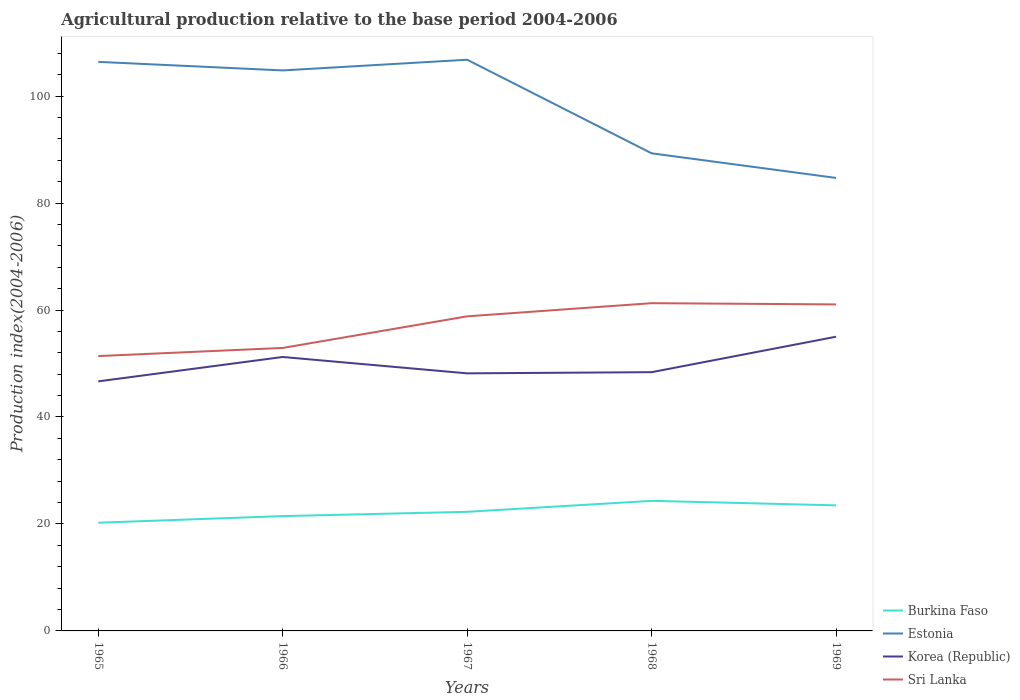Does the line corresponding to Estonia intersect with the line corresponding to Korea (Republic)?
Offer a very short reply. No. Across all years, what is the maximum agricultural production index in Burkina Faso?
Give a very brief answer. 20.23. In which year was the agricultural production index in Burkina Faso maximum?
Provide a succinct answer. 1965. What is the total agricultural production index in Sri Lanka in the graph?
Offer a terse response. -9.66. What is the difference between the highest and the second highest agricultural production index in Sri Lanka?
Your answer should be very brief. 9.89. What is the difference between the highest and the lowest agricultural production index in Sri Lanka?
Ensure brevity in your answer.  3. How many years are there in the graph?
Offer a very short reply. 5. Does the graph contain any zero values?
Your answer should be very brief. No. Does the graph contain grids?
Offer a very short reply. No. Where does the legend appear in the graph?
Offer a terse response. Bottom right. How many legend labels are there?
Keep it short and to the point. 4. How are the legend labels stacked?
Give a very brief answer. Vertical. What is the title of the graph?
Provide a succinct answer. Agricultural production relative to the base period 2004-2006. What is the label or title of the X-axis?
Provide a short and direct response. Years. What is the label or title of the Y-axis?
Offer a terse response. Production index(2004-2006). What is the Production index(2004-2006) in Burkina Faso in 1965?
Keep it short and to the point. 20.23. What is the Production index(2004-2006) in Estonia in 1965?
Offer a very short reply. 106.4. What is the Production index(2004-2006) of Korea (Republic) in 1965?
Make the answer very short. 46.66. What is the Production index(2004-2006) in Sri Lanka in 1965?
Your answer should be very brief. 51.39. What is the Production index(2004-2006) of Burkina Faso in 1966?
Ensure brevity in your answer.  21.47. What is the Production index(2004-2006) of Estonia in 1966?
Provide a succinct answer. 104.8. What is the Production index(2004-2006) of Korea (Republic) in 1966?
Make the answer very short. 51.22. What is the Production index(2004-2006) of Sri Lanka in 1966?
Offer a very short reply. 52.91. What is the Production index(2004-2006) in Burkina Faso in 1967?
Offer a terse response. 22.27. What is the Production index(2004-2006) in Estonia in 1967?
Provide a short and direct response. 106.8. What is the Production index(2004-2006) in Korea (Republic) in 1967?
Provide a succinct answer. 48.16. What is the Production index(2004-2006) of Sri Lanka in 1967?
Offer a terse response. 58.82. What is the Production index(2004-2006) of Burkina Faso in 1968?
Provide a short and direct response. 24.32. What is the Production index(2004-2006) of Estonia in 1968?
Your answer should be very brief. 89.3. What is the Production index(2004-2006) of Korea (Republic) in 1968?
Provide a succinct answer. 48.38. What is the Production index(2004-2006) in Sri Lanka in 1968?
Your answer should be compact. 61.28. What is the Production index(2004-2006) in Burkina Faso in 1969?
Provide a succinct answer. 23.48. What is the Production index(2004-2006) of Estonia in 1969?
Your response must be concise. 84.7. What is the Production index(2004-2006) of Korea (Republic) in 1969?
Provide a succinct answer. 55.01. What is the Production index(2004-2006) of Sri Lanka in 1969?
Provide a succinct answer. 61.05. Across all years, what is the maximum Production index(2004-2006) in Burkina Faso?
Give a very brief answer. 24.32. Across all years, what is the maximum Production index(2004-2006) of Estonia?
Your response must be concise. 106.8. Across all years, what is the maximum Production index(2004-2006) in Korea (Republic)?
Offer a very short reply. 55.01. Across all years, what is the maximum Production index(2004-2006) of Sri Lanka?
Your answer should be very brief. 61.28. Across all years, what is the minimum Production index(2004-2006) of Burkina Faso?
Offer a terse response. 20.23. Across all years, what is the minimum Production index(2004-2006) of Estonia?
Offer a very short reply. 84.7. Across all years, what is the minimum Production index(2004-2006) of Korea (Republic)?
Provide a succinct answer. 46.66. Across all years, what is the minimum Production index(2004-2006) of Sri Lanka?
Your answer should be compact. 51.39. What is the total Production index(2004-2006) in Burkina Faso in the graph?
Offer a terse response. 111.77. What is the total Production index(2004-2006) of Estonia in the graph?
Your response must be concise. 492. What is the total Production index(2004-2006) in Korea (Republic) in the graph?
Your answer should be very brief. 249.43. What is the total Production index(2004-2006) in Sri Lanka in the graph?
Offer a terse response. 285.45. What is the difference between the Production index(2004-2006) in Burkina Faso in 1965 and that in 1966?
Make the answer very short. -1.24. What is the difference between the Production index(2004-2006) in Estonia in 1965 and that in 1966?
Offer a very short reply. 1.6. What is the difference between the Production index(2004-2006) in Korea (Republic) in 1965 and that in 1966?
Offer a terse response. -4.56. What is the difference between the Production index(2004-2006) of Sri Lanka in 1965 and that in 1966?
Make the answer very short. -1.52. What is the difference between the Production index(2004-2006) in Burkina Faso in 1965 and that in 1967?
Give a very brief answer. -2.04. What is the difference between the Production index(2004-2006) of Estonia in 1965 and that in 1967?
Give a very brief answer. -0.4. What is the difference between the Production index(2004-2006) of Korea (Republic) in 1965 and that in 1967?
Provide a short and direct response. -1.5. What is the difference between the Production index(2004-2006) of Sri Lanka in 1965 and that in 1967?
Give a very brief answer. -7.43. What is the difference between the Production index(2004-2006) in Burkina Faso in 1965 and that in 1968?
Your answer should be compact. -4.09. What is the difference between the Production index(2004-2006) of Korea (Republic) in 1965 and that in 1968?
Make the answer very short. -1.72. What is the difference between the Production index(2004-2006) in Sri Lanka in 1965 and that in 1968?
Make the answer very short. -9.89. What is the difference between the Production index(2004-2006) of Burkina Faso in 1965 and that in 1969?
Offer a very short reply. -3.25. What is the difference between the Production index(2004-2006) in Estonia in 1965 and that in 1969?
Your answer should be very brief. 21.7. What is the difference between the Production index(2004-2006) in Korea (Republic) in 1965 and that in 1969?
Your answer should be compact. -8.35. What is the difference between the Production index(2004-2006) in Sri Lanka in 1965 and that in 1969?
Give a very brief answer. -9.66. What is the difference between the Production index(2004-2006) of Estonia in 1966 and that in 1967?
Make the answer very short. -2. What is the difference between the Production index(2004-2006) of Korea (Republic) in 1966 and that in 1967?
Offer a terse response. 3.06. What is the difference between the Production index(2004-2006) in Sri Lanka in 1966 and that in 1967?
Make the answer very short. -5.91. What is the difference between the Production index(2004-2006) of Burkina Faso in 1966 and that in 1968?
Make the answer very short. -2.85. What is the difference between the Production index(2004-2006) in Korea (Republic) in 1966 and that in 1968?
Your response must be concise. 2.84. What is the difference between the Production index(2004-2006) in Sri Lanka in 1966 and that in 1968?
Make the answer very short. -8.37. What is the difference between the Production index(2004-2006) of Burkina Faso in 1966 and that in 1969?
Provide a short and direct response. -2.01. What is the difference between the Production index(2004-2006) in Estonia in 1966 and that in 1969?
Your answer should be very brief. 20.1. What is the difference between the Production index(2004-2006) of Korea (Republic) in 1966 and that in 1969?
Offer a terse response. -3.79. What is the difference between the Production index(2004-2006) in Sri Lanka in 1966 and that in 1969?
Offer a very short reply. -8.14. What is the difference between the Production index(2004-2006) of Burkina Faso in 1967 and that in 1968?
Ensure brevity in your answer.  -2.05. What is the difference between the Production index(2004-2006) in Korea (Republic) in 1967 and that in 1968?
Offer a very short reply. -0.22. What is the difference between the Production index(2004-2006) of Sri Lanka in 1967 and that in 1968?
Offer a terse response. -2.46. What is the difference between the Production index(2004-2006) of Burkina Faso in 1967 and that in 1969?
Your answer should be compact. -1.21. What is the difference between the Production index(2004-2006) in Estonia in 1967 and that in 1969?
Your answer should be very brief. 22.1. What is the difference between the Production index(2004-2006) of Korea (Republic) in 1967 and that in 1969?
Your response must be concise. -6.85. What is the difference between the Production index(2004-2006) in Sri Lanka in 1967 and that in 1969?
Give a very brief answer. -2.23. What is the difference between the Production index(2004-2006) of Burkina Faso in 1968 and that in 1969?
Provide a succinct answer. 0.84. What is the difference between the Production index(2004-2006) of Estonia in 1968 and that in 1969?
Your answer should be compact. 4.6. What is the difference between the Production index(2004-2006) of Korea (Republic) in 1968 and that in 1969?
Your response must be concise. -6.63. What is the difference between the Production index(2004-2006) in Sri Lanka in 1968 and that in 1969?
Offer a very short reply. 0.23. What is the difference between the Production index(2004-2006) of Burkina Faso in 1965 and the Production index(2004-2006) of Estonia in 1966?
Keep it short and to the point. -84.57. What is the difference between the Production index(2004-2006) in Burkina Faso in 1965 and the Production index(2004-2006) in Korea (Republic) in 1966?
Give a very brief answer. -30.99. What is the difference between the Production index(2004-2006) in Burkina Faso in 1965 and the Production index(2004-2006) in Sri Lanka in 1966?
Offer a very short reply. -32.68. What is the difference between the Production index(2004-2006) of Estonia in 1965 and the Production index(2004-2006) of Korea (Republic) in 1966?
Provide a succinct answer. 55.18. What is the difference between the Production index(2004-2006) in Estonia in 1965 and the Production index(2004-2006) in Sri Lanka in 1966?
Ensure brevity in your answer.  53.49. What is the difference between the Production index(2004-2006) of Korea (Republic) in 1965 and the Production index(2004-2006) of Sri Lanka in 1966?
Your answer should be very brief. -6.25. What is the difference between the Production index(2004-2006) in Burkina Faso in 1965 and the Production index(2004-2006) in Estonia in 1967?
Offer a terse response. -86.57. What is the difference between the Production index(2004-2006) of Burkina Faso in 1965 and the Production index(2004-2006) of Korea (Republic) in 1967?
Give a very brief answer. -27.93. What is the difference between the Production index(2004-2006) of Burkina Faso in 1965 and the Production index(2004-2006) of Sri Lanka in 1967?
Offer a terse response. -38.59. What is the difference between the Production index(2004-2006) of Estonia in 1965 and the Production index(2004-2006) of Korea (Republic) in 1967?
Make the answer very short. 58.24. What is the difference between the Production index(2004-2006) in Estonia in 1965 and the Production index(2004-2006) in Sri Lanka in 1967?
Ensure brevity in your answer.  47.58. What is the difference between the Production index(2004-2006) in Korea (Republic) in 1965 and the Production index(2004-2006) in Sri Lanka in 1967?
Offer a very short reply. -12.16. What is the difference between the Production index(2004-2006) in Burkina Faso in 1965 and the Production index(2004-2006) in Estonia in 1968?
Offer a very short reply. -69.07. What is the difference between the Production index(2004-2006) of Burkina Faso in 1965 and the Production index(2004-2006) of Korea (Republic) in 1968?
Your answer should be compact. -28.15. What is the difference between the Production index(2004-2006) of Burkina Faso in 1965 and the Production index(2004-2006) of Sri Lanka in 1968?
Provide a short and direct response. -41.05. What is the difference between the Production index(2004-2006) of Estonia in 1965 and the Production index(2004-2006) of Korea (Republic) in 1968?
Your answer should be very brief. 58.02. What is the difference between the Production index(2004-2006) in Estonia in 1965 and the Production index(2004-2006) in Sri Lanka in 1968?
Offer a terse response. 45.12. What is the difference between the Production index(2004-2006) in Korea (Republic) in 1965 and the Production index(2004-2006) in Sri Lanka in 1968?
Provide a succinct answer. -14.62. What is the difference between the Production index(2004-2006) of Burkina Faso in 1965 and the Production index(2004-2006) of Estonia in 1969?
Keep it short and to the point. -64.47. What is the difference between the Production index(2004-2006) of Burkina Faso in 1965 and the Production index(2004-2006) of Korea (Republic) in 1969?
Your response must be concise. -34.78. What is the difference between the Production index(2004-2006) of Burkina Faso in 1965 and the Production index(2004-2006) of Sri Lanka in 1969?
Your answer should be compact. -40.82. What is the difference between the Production index(2004-2006) in Estonia in 1965 and the Production index(2004-2006) in Korea (Republic) in 1969?
Offer a terse response. 51.39. What is the difference between the Production index(2004-2006) in Estonia in 1965 and the Production index(2004-2006) in Sri Lanka in 1969?
Ensure brevity in your answer.  45.35. What is the difference between the Production index(2004-2006) of Korea (Republic) in 1965 and the Production index(2004-2006) of Sri Lanka in 1969?
Provide a short and direct response. -14.39. What is the difference between the Production index(2004-2006) in Burkina Faso in 1966 and the Production index(2004-2006) in Estonia in 1967?
Provide a short and direct response. -85.33. What is the difference between the Production index(2004-2006) of Burkina Faso in 1966 and the Production index(2004-2006) of Korea (Republic) in 1967?
Provide a succinct answer. -26.69. What is the difference between the Production index(2004-2006) in Burkina Faso in 1966 and the Production index(2004-2006) in Sri Lanka in 1967?
Offer a very short reply. -37.35. What is the difference between the Production index(2004-2006) in Estonia in 1966 and the Production index(2004-2006) in Korea (Republic) in 1967?
Your answer should be compact. 56.64. What is the difference between the Production index(2004-2006) in Estonia in 1966 and the Production index(2004-2006) in Sri Lanka in 1967?
Provide a short and direct response. 45.98. What is the difference between the Production index(2004-2006) in Korea (Republic) in 1966 and the Production index(2004-2006) in Sri Lanka in 1967?
Your response must be concise. -7.6. What is the difference between the Production index(2004-2006) of Burkina Faso in 1966 and the Production index(2004-2006) of Estonia in 1968?
Your answer should be compact. -67.83. What is the difference between the Production index(2004-2006) of Burkina Faso in 1966 and the Production index(2004-2006) of Korea (Republic) in 1968?
Give a very brief answer. -26.91. What is the difference between the Production index(2004-2006) in Burkina Faso in 1966 and the Production index(2004-2006) in Sri Lanka in 1968?
Provide a short and direct response. -39.81. What is the difference between the Production index(2004-2006) in Estonia in 1966 and the Production index(2004-2006) in Korea (Republic) in 1968?
Provide a succinct answer. 56.42. What is the difference between the Production index(2004-2006) in Estonia in 1966 and the Production index(2004-2006) in Sri Lanka in 1968?
Keep it short and to the point. 43.52. What is the difference between the Production index(2004-2006) of Korea (Republic) in 1966 and the Production index(2004-2006) of Sri Lanka in 1968?
Offer a very short reply. -10.06. What is the difference between the Production index(2004-2006) in Burkina Faso in 1966 and the Production index(2004-2006) in Estonia in 1969?
Provide a succinct answer. -63.23. What is the difference between the Production index(2004-2006) in Burkina Faso in 1966 and the Production index(2004-2006) in Korea (Republic) in 1969?
Make the answer very short. -33.54. What is the difference between the Production index(2004-2006) of Burkina Faso in 1966 and the Production index(2004-2006) of Sri Lanka in 1969?
Offer a very short reply. -39.58. What is the difference between the Production index(2004-2006) in Estonia in 1966 and the Production index(2004-2006) in Korea (Republic) in 1969?
Offer a very short reply. 49.79. What is the difference between the Production index(2004-2006) of Estonia in 1966 and the Production index(2004-2006) of Sri Lanka in 1969?
Your answer should be compact. 43.75. What is the difference between the Production index(2004-2006) of Korea (Republic) in 1966 and the Production index(2004-2006) of Sri Lanka in 1969?
Your response must be concise. -9.83. What is the difference between the Production index(2004-2006) in Burkina Faso in 1967 and the Production index(2004-2006) in Estonia in 1968?
Provide a succinct answer. -67.03. What is the difference between the Production index(2004-2006) of Burkina Faso in 1967 and the Production index(2004-2006) of Korea (Republic) in 1968?
Keep it short and to the point. -26.11. What is the difference between the Production index(2004-2006) in Burkina Faso in 1967 and the Production index(2004-2006) in Sri Lanka in 1968?
Your answer should be compact. -39.01. What is the difference between the Production index(2004-2006) of Estonia in 1967 and the Production index(2004-2006) of Korea (Republic) in 1968?
Provide a short and direct response. 58.42. What is the difference between the Production index(2004-2006) in Estonia in 1967 and the Production index(2004-2006) in Sri Lanka in 1968?
Provide a short and direct response. 45.52. What is the difference between the Production index(2004-2006) of Korea (Republic) in 1967 and the Production index(2004-2006) of Sri Lanka in 1968?
Ensure brevity in your answer.  -13.12. What is the difference between the Production index(2004-2006) in Burkina Faso in 1967 and the Production index(2004-2006) in Estonia in 1969?
Offer a very short reply. -62.43. What is the difference between the Production index(2004-2006) in Burkina Faso in 1967 and the Production index(2004-2006) in Korea (Republic) in 1969?
Give a very brief answer. -32.74. What is the difference between the Production index(2004-2006) in Burkina Faso in 1967 and the Production index(2004-2006) in Sri Lanka in 1969?
Give a very brief answer. -38.78. What is the difference between the Production index(2004-2006) of Estonia in 1967 and the Production index(2004-2006) of Korea (Republic) in 1969?
Your response must be concise. 51.79. What is the difference between the Production index(2004-2006) of Estonia in 1967 and the Production index(2004-2006) of Sri Lanka in 1969?
Your answer should be very brief. 45.75. What is the difference between the Production index(2004-2006) of Korea (Republic) in 1967 and the Production index(2004-2006) of Sri Lanka in 1969?
Ensure brevity in your answer.  -12.89. What is the difference between the Production index(2004-2006) of Burkina Faso in 1968 and the Production index(2004-2006) of Estonia in 1969?
Your answer should be compact. -60.38. What is the difference between the Production index(2004-2006) of Burkina Faso in 1968 and the Production index(2004-2006) of Korea (Republic) in 1969?
Your answer should be compact. -30.69. What is the difference between the Production index(2004-2006) of Burkina Faso in 1968 and the Production index(2004-2006) of Sri Lanka in 1969?
Provide a short and direct response. -36.73. What is the difference between the Production index(2004-2006) of Estonia in 1968 and the Production index(2004-2006) of Korea (Republic) in 1969?
Offer a terse response. 34.29. What is the difference between the Production index(2004-2006) of Estonia in 1968 and the Production index(2004-2006) of Sri Lanka in 1969?
Give a very brief answer. 28.25. What is the difference between the Production index(2004-2006) in Korea (Republic) in 1968 and the Production index(2004-2006) in Sri Lanka in 1969?
Ensure brevity in your answer.  -12.67. What is the average Production index(2004-2006) of Burkina Faso per year?
Provide a succinct answer. 22.35. What is the average Production index(2004-2006) in Estonia per year?
Make the answer very short. 98.4. What is the average Production index(2004-2006) of Korea (Republic) per year?
Keep it short and to the point. 49.89. What is the average Production index(2004-2006) in Sri Lanka per year?
Your response must be concise. 57.09. In the year 1965, what is the difference between the Production index(2004-2006) of Burkina Faso and Production index(2004-2006) of Estonia?
Provide a short and direct response. -86.17. In the year 1965, what is the difference between the Production index(2004-2006) of Burkina Faso and Production index(2004-2006) of Korea (Republic)?
Give a very brief answer. -26.43. In the year 1965, what is the difference between the Production index(2004-2006) in Burkina Faso and Production index(2004-2006) in Sri Lanka?
Provide a short and direct response. -31.16. In the year 1965, what is the difference between the Production index(2004-2006) of Estonia and Production index(2004-2006) of Korea (Republic)?
Keep it short and to the point. 59.74. In the year 1965, what is the difference between the Production index(2004-2006) in Estonia and Production index(2004-2006) in Sri Lanka?
Your response must be concise. 55.01. In the year 1965, what is the difference between the Production index(2004-2006) of Korea (Republic) and Production index(2004-2006) of Sri Lanka?
Give a very brief answer. -4.73. In the year 1966, what is the difference between the Production index(2004-2006) of Burkina Faso and Production index(2004-2006) of Estonia?
Offer a terse response. -83.33. In the year 1966, what is the difference between the Production index(2004-2006) in Burkina Faso and Production index(2004-2006) in Korea (Republic)?
Your response must be concise. -29.75. In the year 1966, what is the difference between the Production index(2004-2006) of Burkina Faso and Production index(2004-2006) of Sri Lanka?
Your response must be concise. -31.44. In the year 1966, what is the difference between the Production index(2004-2006) of Estonia and Production index(2004-2006) of Korea (Republic)?
Ensure brevity in your answer.  53.58. In the year 1966, what is the difference between the Production index(2004-2006) of Estonia and Production index(2004-2006) of Sri Lanka?
Ensure brevity in your answer.  51.89. In the year 1966, what is the difference between the Production index(2004-2006) in Korea (Republic) and Production index(2004-2006) in Sri Lanka?
Give a very brief answer. -1.69. In the year 1967, what is the difference between the Production index(2004-2006) in Burkina Faso and Production index(2004-2006) in Estonia?
Keep it short and to the point. -84.53. In the year 1967, what is the difference between the Production index(2004-2006) of Burkina Faso and Production index(2004-2006) of Korea (Republic)?
Keep it short and to the point. -25.89. In the year 1967, what is the difference between the Production index(2004-2006) of Burkina Faso and Production index(2004-2006) of Sri Lanka?
Provide a succinct answer. -36.55. In the year 1967, what is the difference between the Production index(2004-2006) in Estonia and Production index(2004-2006) in Korea (Republic)?
Offer a very short reply. 58.64. In the year 1967, what is the difference between the Production index(2004-2006) in Estonia and Production index(2004-2006) in Sri Lanka?
Give a very brief answer. 47.98. In the year 1967, what is the difference between the Production index(2004-2006) in Korea (Republic) and Production index(2004-2006) in Sri Lanka?
Give a very brief answer. -10.66. In the year 1968, what is the difference between the Production index(2004-2006) in Burkina Faso and Production index(2004-2006) in Estonia?
Offer a very short reply. -64.98. In the year 1968, what is the difference between the Production index(2004-2006) in Burkina Faso and Production index(2004-2006) in Korea (Republic)?
Keep it short and to the point. -24.06. In the year 1968, what is the difference between the Production index(2004-2006) of Burkina Faso and Production index(2004-2006) of Sri Lanka?
Ensure brevity in your answer.  -36.96. In the year 1968, what is the difference between the Production index(2004-2006) of Estonia and Production index(2004-2006) of Korea (Republic)?
Offer a very short reply. 40.92. In the year 1968, what is the difference between the Production index(2004-2006) in Estonia and Production index(2004-2006) in Sri Lanka?
Offer a terse response. 28.02. In the year 1968, what is the difference between the Production index(2004-2006) in Korea (Republic) and Production index(2004-2006) in Sri Lanka?
Offer a terse response. -12.9. In the year 1969, what is the difference between the Production index(2004-2006) in Burkina Faso and Production index(2004-2006) in Estonia?
Give a very brief answer. -61.22. In the year 1969, what is the difference between the Production index(2004-2006) in Burkina Faso and Production index(2004-2006) in Korea (Republic)?
Offer a very short reply. -31.53. In the year 1969, what is the difference between the Production index(2004-2006) in Burkina Faso and Production index(2004-2006) in Sri Lanka?
Make the answer very short. -37.57. In the year 1969, what is the difference between the Production index(2004-2006) of Estonia and Production index(2004-2006) of Korea (Republic)?
Offer a terse response. 29.69. In the year 1969, what is the difference between the Production index(2004-2006) of Estonia and Production index(2004-2006) of Sri Lanka?
Keep it short and to the point. 23.65. In the year 1969, what is the difference between the Production index(2004-2006) of Korea (Republic) and Production index(2004-2006) of Sri Lanka?
Give a very brief answer. -6.04. What is the ratio of the Production index(2004-2006) of Burkina Faso in 1965 to that in 1966?
Give a very brief answer. 0.94. What is the ratio of the Production index(2004-2006) in Estonia in 1965 to that in 1966?
Your answer should be compact. 1.02. What is the ratio of the Production index(2004-2006) of Korea (Republic) in 1965 to that in 1966?
Your response must be concise. 0.91. What is the ratio of the Production index(2004-2006) of Sri Lanka in 1965 to that in 1966?
Offer a terse response. 0.97. What is the ratio of the Production index(2004-2006) in Burkina Faso in 1965 to that in 1967?
Provide a succinct answer. 0.91. What is the ratio of the Production index(2004-2006) of Estonia in 1965 to that in 1967?
Give a very brief answer. 1. What is the ratio of the Production index(2004-2006) of Korea (Republic) in 1965 to that in 1967?
Provide a short and direct response. 0.97. What is the ratio of the Production index(2004-2006) in Sri Lanka in 1965 to that in 1967?
Your answer should be compact. 0.87. What is the ratio of the Production index(2004-2006) of Burkina Faso in 1965 to that in 1968?
Make the answer very short. 0.83. What is the ratio of the Production index(2004-2006) in Estonia in 1965 to that in 1968?
Your response must be concise. 1.19. What is the ratio of the Production index(2004-2006) of Korea (Republic) in 1965 to that in 1968?
Provide a short and direct response. 0.96. What is the ratio of the Production index(2004-2006) in Sri Lanka in 1965 to that in 1968?
Make the answer very short. 0.84. What is the ratio of the Production index(2004-2006) of Burkina Faso in 1965 to that in 1969?
Ensure brevity in your answer.  0.86. What is the ratio of the Production index(2004-2006) of Estonia in 1965 to that in 1969?
Make the answer very short. 1.26. What is the ratio of the Production index(2004-2006) in Korea (Republic) in 1965 to that in 1969?
Give a very brief answer. 0.85. What is the ratio of the Production index(2004-2006) of Sri Lanka in 1965 to that in 1969?
Provide a short and direct response. 0.84. What is the ratio of the Production index(2004-2006) of Burkina Faso in 1966 to that in 1967?
Make the answer very short. 0.96. What is the ratio of the Production index(2004-2006) of Estonia in 1966 to that in 1967?
Keep it short and to the point. 0.98. What is the ratio of the Production index(2004-2006) in Korea (Republic) in 1966 to that in 1967?
Offer a very short reply. 1.06. What is the ratio of the Production index(2004-2006) of Sri Lanka in 1966 to that in 1967?
Give a very brief answer. 0.9. What is the ratio of the Production index(2004-2006) in Burkina Faso in 1966 to that in 1968?
Make the answer very short. 0.88. What is the ratio of the Production index(2004-2006) in Estonia in 1966 to that in 1968?
Your answer should be compact. 1.17. What is the ratio of the Production index(2004-2006) of Korea (Republic) in 1966 to that in 1968?
Provide a succinct answer. 1.06. What is the ratio of the Production index(2004-2006) in Sri Lanka in 1966 to that in 1968?
Keep it short and to the point. 0.86. What is the ratio of the Production index(2004-2006) of Burkina Faso in 1966 to that in 1969?
Your answer should be very brief. 0.91. What is the ratio of the Production index(2004-2006) in Estonia in 1966 to that in 1969?
Provide a short and direct response. 1.24. What is the ratio of the Production index(2004-2006) of Korea (Republic) in 1966 to that in 1969?
Offer a very short reply. 0.93. What is the ratio of the Production index(2004-2006) in Sri Lanka in 1966 to that in 1969?
Your answer should be compact. 0.87. What is the ratio of the Production index(2004-2006) of Burkina Faso in 1967 to that in 1968?
Offer a terse response. 0.92. What is the ratio of the Production index(2004-2006) of Estonia in 1967 to that in 1968?
Provide a short and direct response. 1.2. What is the ratio of the Production index(2004-2006) of Korea (Republic) in 1967 to that in 1968?
Offer a very short reply. 1. What is the ratio of the Production index(2004-2006) in Sri Lanka in 1967 to that in 1968?
Your answer should be very brief. 0.96. What is the ratio of the Production index(2004-2006) in Burkina Faso in 1967 to that in 1969?
Provide a succinct answer. 0.95. What is the ratio of the Production index(2004-2006) of Estonia in 1967 to that in 1969?
Give a very brief answer. 1.26. What is the ratio of the Production index(2004-2006) of Korea (Republic) in 1967 to that in 1969?
Your answer should be compact. 0.88. What is the ratio of the Production index(2004-2006) of Sri Lanka in 1967 to that in 1969?
Offer a very short reply. 0.96. What is the ratio of the Production index(2004-2006) in Burkina Faso in 1968 to that in 1969?
Ensure brevity in your answer.  1.04. What is the ratio of the Production index(2004-2006) in Estonia in 1968 to that in 1969?
Keep it short and to the point. 1.05. What is the ratio of the Production index(2004-2006) in Korea (Republic) in 1968 to that in 1969?
Keep it short and to the point. 0.88. What is the difference between the highest and the second highest Production index(2004-2006) in Burkina Faso?
Provide a succinct answer. 0.84. What is the difference between the highest and the second highest Production index(2004-2006) in Korea (Republic)?
Offer a very short reply. 3.79. What is the difference between the highest and the second highest Production index(2004-2006) in Sri Lanka?
Your response must be concise. 0.23. What is the difference between the highest and the lowest Production index(2004-2006) of Burkina Faso?
Provide a short and direct response. 4.09. What is the difference between the highest and the lowest Production index(2004-2006) of Estonia?
Keep it short and to the point. 22.1. What is the difference between the highest and the lowest Production index(2004-2006) in Korea (Republic)?
Provide a short and direct response. 8.35. What is the difference between the highest and the lowest Production index(2004-2006) in Sri Lanka?
Give a very brief answer. 9.89. 